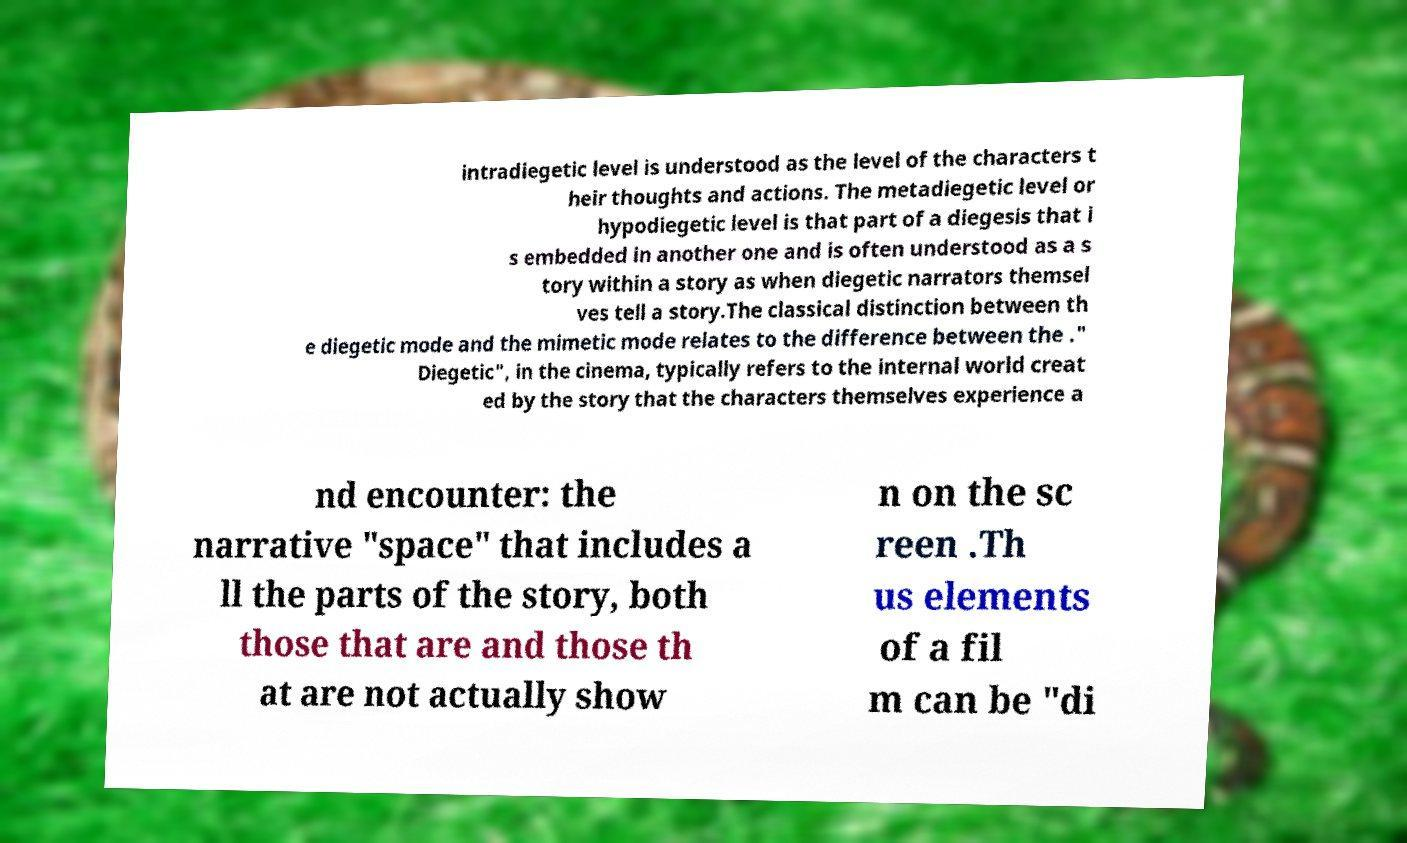Could you extract and type out the text from this image? intradiegetic level is understood as the level of the characters t heir thoughts and actions. The metadiegetic level or hypodiegetic level is that part of a diegesis that i s embedded in another one and is often understood as a s tory within a story as when diegetic narrators themsel ves tell a story.The classical distinction between th e diegetic mode and the mimetic mode relates to the difference between the ." Diegetic", in the cinema, typically refers to the internal world creat ed by the story that the characters themselves experience a nd encounter: the narrative "space" that includes a ll the parts of the story, both those that are and those th at are not actually show n on the sc reen .Th us elements of a fil m can be "di 